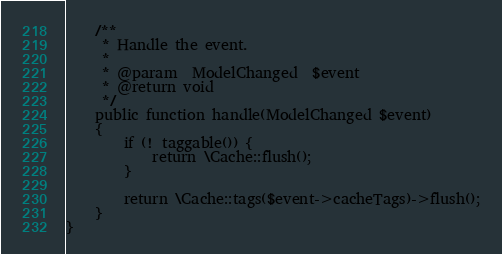<code> <loc_0><loc_0><loc_500><loc_500><_PHP_>
    /**
     * Handle the event.
     *
     * @param  ModelChanged  $event
     * @return void
     */
    public function handle(ModelChanged $event)
    {
        if (! taggable()) {
            return \Cache::flush();
        }
        
        return \Cache::tags($event->cacheTags)->flush();
    }
}
</code> 